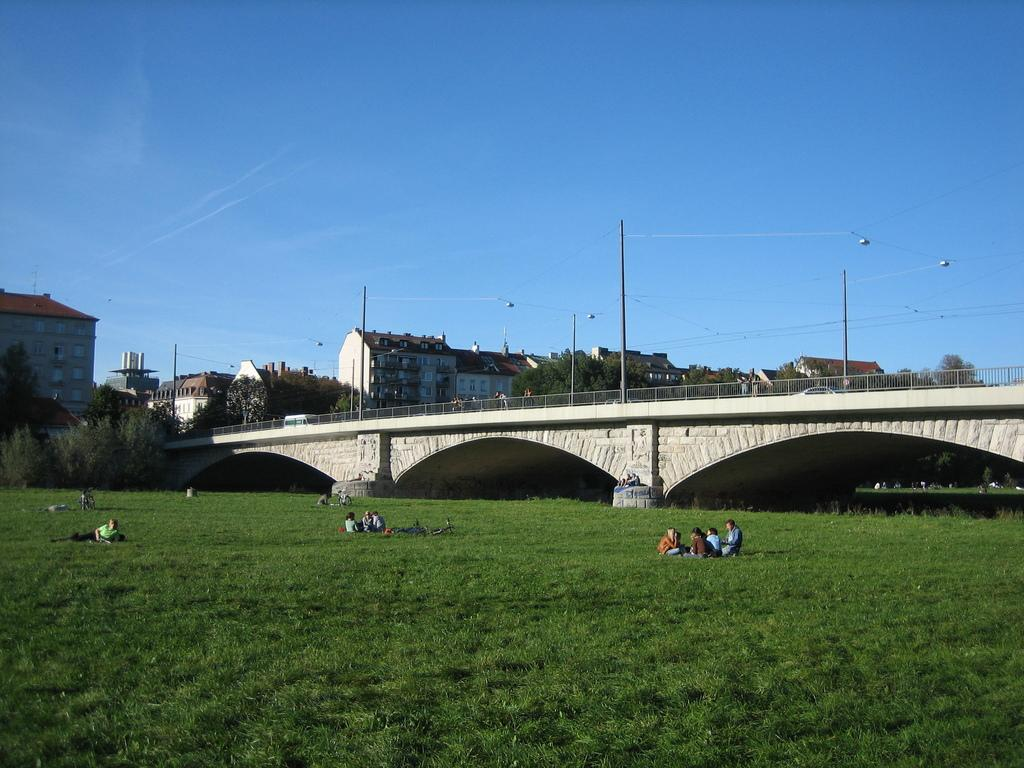What are the people in the image doing? There are people sitting in the grass and people on a bridge. What can be seen in the background of the image? There are trees, electrical poles, and a fence in the image. What are some features of the electrical poles? Cables are visible on the electrical poles, and lights are present on them. What type of truck can be seen driving through the grass in the image? There is no truck present in the image; it features people sitting in the grass and on a bridge. 